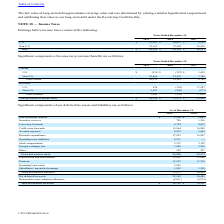From Cts Corporation's financial document, Which years does the table provide information for Significant components of income tax provision/(benefit)? The document contains multiple relevant values: 2019, 2018, 2017. From the document: "2019 2018 2017 2019 2018 2017 2019 2018 2017..." Also, What was the current income tax provision  for U.S. in 2018? According to the financial document, (397) (in thousands). The relevant text states: "U.S. $ (391) $ (397) $ 1,635..." Also, What was the current income tax provision for Non-U.S. in 2017? According to the financial document, 7,150 (in thousands). The relevant text states: "Non-U.S. 10,666 12,538 7,150..." Also, How many years did the total deferred amount of income tax provision exceed $1,000 thousand? Counting the relevant items in the document: 2019, 2017, I find 2 instances. The key data points involved are: 2017, 2019. Also, can you calculate: What was the change in the total current income tax provision  between 2017 and 2018? Based on the calculation: 12,141-8,785, the result is 3356 (in thousands). This is based on the information: "Total Current 10,275 12,141 8,785 Total Current 10,275 12,141 8,785..." The key data points involved are: 12,141, 8,785. Also, can you calculate: What was the percentage change in the Total provision for income taxes between 2018 and 2019? To answer this question, I need to perform calculations using the financial data. The calculation is: (14,120-11,571)/11,571, which equals 22.03 (percentage). This is based on the information: "Total provision for income taxes $ 14,120 $ 11,571 $ 25,805 Total provision for income taxes $ 14,120 $ 11,571 $ 25,805..." The key data points involved are: 11,571, 14,120. 